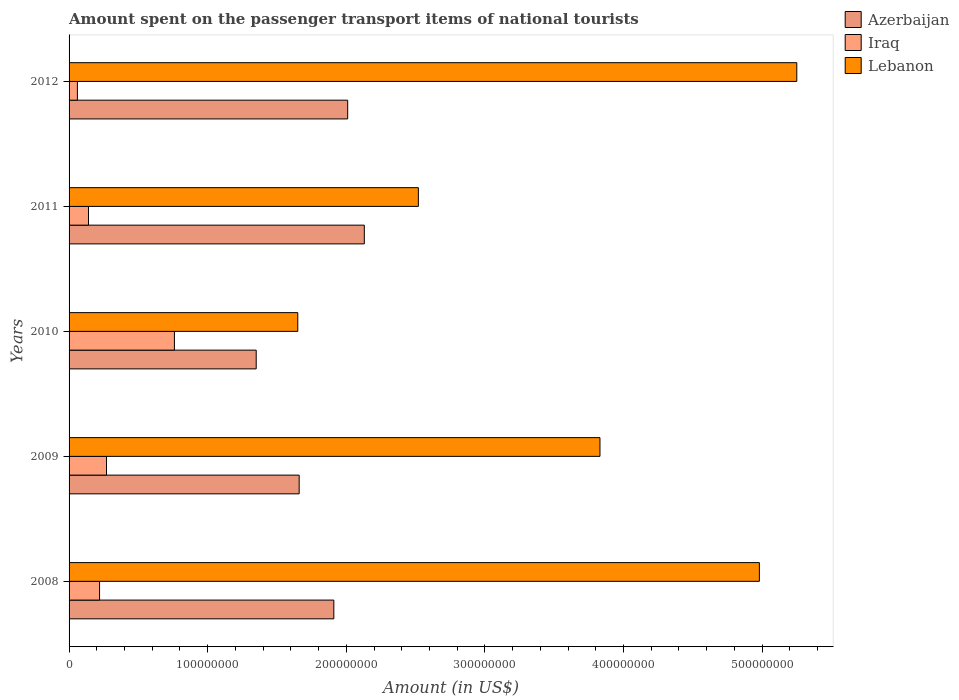How many different coloured bars are there?
Your response must be concise. 3. Are the number of bars per tick equal to the number of legend labels?
Your response must be concise. Yes. How many bars are there on the 4th tick from the bottom?
Keep it short and to the point. 3. In how many cases, is the number of bars for a given year not equal to the number of legend labels?
Your answer should be compact. 0. What is the amount spent on the passenger transport items of national tourists in Azerbaijan in 2009?
Your answer should be very brief. 1.66e+08. Across all years, what is the maximum amount spent on the passenger transport items of national tourists in Iraq?
Keep it short and to the point. 7.60e+07. Across all years, what is the minimum amount spent on the passenger transport items of national tourists in Lebanon?
Keep it short and to the point. 1.65e+08. In which year was the amount spent on the passenger transport items of national tourists in Azerbaijan maximum?
Give a very brief answer. 2011. In which year was the amount spent on the passenger transport items of national tourists in Azerbaijan minimum?
Offer a very short reply. 2010. What is the total amount spent on the passenger transport items of national tourists in Azerbaijan in the graph?
Provide a succinct answer. 9.06e+08. What is the difference between the amount spent on the passenger transport items of national tourists in Azerbaijan in 2008 and that in 2011?
Give a very brief answer. -2.20e+07. What is the difference between the amount spent on the passenger transport items of national tourists in Azerbaijan in 2011 and the amount spent on the passenger transport items of national tourists in Iraq in 2012?
Provide a short and direct response. 2.07e+08. What is the average amount spent on the passenger transport items of national tourists in Azerbaijan per year?
Your response must be concise. 1.81e+08. In the year 2011, what is the difference between the amount spent on the passenger transport items of national tourists in Iraq and amount spent on the passenger transport items of national tourists in Azerbaijan?
Provide a succinct answer. -1.99e+08. In how many years, is the amount spent on the passenger transport items of national tourists in Azerbaijan greater than 160000000 US$?
Keep it short and to the point. 4. What is the ratio of the amount spent on the passenger transport items of national tourists in Azerbaijan in 2009 to that in 2010?
Your response must be concise. 1.23. Is the difference between the amount spent on the passenger transport items of national tourists in Iraq in 2010 and 2011 greater than the difference between the amount spent on the passenger transport items of national tourists in Azerbaijan in 2010 and 2011?
Provide a succinct answer. Yes. What is the difference between the highest and the second highest amount spent on the passenger transport items of national tourists in Lebanon?
Ensure brevity in your answer.  2.70e+07. What is the difference between the highest and the lowest amount spent on the passenger transport items of national tourists in Azerbaijan?
Your answer should be compact. 7.80e+07. Is the sum of the amount spent on the passenger transport items of national tourists in Iraq in 2010 and 2011 greater than the maximum amount spent on the passenger transport items of national tourists in Lebanon across all years?
Ensure brevity in your answer.  No. What does the 1st bar from the top in 2012 represents?
Give a very brief answer. Lebanon. What does the 2nd bar from the bottom in 2011 represents?
Ensure brevity in your answer.  Iraq. Is it the case that in every year, the sum of the amount spent on the passenger transport items of national tourists in Azerbaijan and amount spent on the passenger transport items of national tourists in Iraq is greater than the amount spent on the passenger transport items of national tourists in Lebanon?
Offer a terse response. No. How many bars are there?
Ensure brevity in your answer.  15. Are all the bars in the graph horizontal?
Provide a short and direct response. Yes. How many years are there in the graph?
Keep it short and to the point. 5. What is the difference between two consecutive major ticks on the X-axis?
Keep it short and to the point. 1.00e+08. Does the graph contain grids?
Your answer should be compact. No. Where does the legend appear in the graph?
Your response must be concise. Top right. How many legend labels are there?
Ensure brevity in your answer.  3. How are the legend labels stacked?
Offer a very short reply. Vertical. What is the title of the graph?
Keep it short and to the point. Amount spent on the passenger transport items of national tourists. What is the Amount (in US$) in Azerbaijan in 2008?
Your answer should be very brief. 1.91e+08. What is the Amount (in US$) of Iraq in 2008?
Provide a short and direct response. 2.20e+07. What is the Amount (in US$) of Lebanon in 2008?
Your response must be concise. 4.98e+08. What is the Amount (in US$) of Azerbaijan in 2009?
Provide a succinct answer. 1.66e+08. What is the Amount (in US$) of Iraq in 2009?
Keep it short and to the point. 2.70e+07. What is the Amount (in US$) of Lebanon in 2009?
Keep it short and to the point. 3.83e+08. What is the Amount (in US$) in Azerbaijan in 2010?
Give a very brief answer. 1.35e+08. What is the Amount (in US$) in Iraq in 2010?
Your response must be concise. 7.60e+07. What is the Amount (in US$) of Lebanon in 2010?
Give a very brief answer. 1.65e+08. What is the Amount (in US$) in Azerbaijan in 2011?
Make the answer very short. 2.13e+08. What is the Amount (in US$) of Iraq in 2011?
Provide a succinct answer. 1.40e+07. What is the Amount (in US$) in Lebanon in 2011?
Keep it short and to the point. 2.52e+08. What is the Amount (in US$) of Azerbaijan in 2012?
Provide a short and direct response. 2.01e+08. What is the Amount (in US$) of Iraq in 2012?
Give a very brief answer. 6.00e+06. What is the Amount (in US$) of Lebanon in 2012?
Give a very brief answer. 5.25e+08. Across all years, what is the maximum Amount (in US$) of Azerbaijan?
Your response must be concise. 2.13e+08. Across all years, what is the maximum Amount (in US$) of Iraq?
Your answer should be very brief. 7.60e+07. Across all years, what is the maximum Amount (in US$) in Lebanon?
Your response must be concise. 5.25e+08. Across all years, what is the minimum Amount (in US$) in Azerbaijan?
Make the answer very short. 1.35e+08. Across all years, what is the minimum Amount (in US$) in Lebanon?
Offer a very short reply. 1.65e+08. What is the total Amount (in US$) of Azerbaijan in the graph?
Provide a succinct answer. 9.06e+08. What is the total Amount (in US$) in Iraq in the graph?
Your response must be concise. 1.45e+08. What is the total Amount (in US$) in Lebanon in the graph?
Your answer should be compact. 1.82e+09. What is the difference between the Amount (in US$) in Azerbaijan in 2008 and that in 2009?
Offer a terse response. 2.50e+07. What is the difference between the Amount (in US$) in Iraq in 2008 and that in 2009?
Provide a short and direct response. -5.00e+06. What is the difference between the Amount (in US$) of Lebanon in 2008 and that in 2009?
Make the answer very short. 1.15e+08. What is the difference between the Amount (in US$) of Azerbaijan in 2008 and that in 2010?
Offer a terse response. 5.60e+07. What is the difference between the Amount (in US$) in Iraq in 2008 and that in 2010?
Provide a short and direct response. -5.40e+07. What is the difference between the Amount (in US$) of Lebanon in 2008 and that in 2010?
Keep it short and to the point. 3.33e+08. What is the difference between the Amount (in US$) of Azerbaijan in 2008 and that in 2011?
Offer a terse response. -2.20e+07. What is the difference between the Amount (in US$) in Iraq in 2008 and that in 2011?
Make the answer very short. 8.00e+06. What is the difference between the Amount (in US$) of Lebanon in 2008 and that in 2011?
Your response must be concise. 2.46e+08. What is the difference between the Amount (in US$) of Azerbaijan in 2008 and that in 2012?
Your answer should be very brief. -1.00e+07. What is the difference between the Amount (in US$) of Iraq in 2008 and that in 2012?
Your response must be concise. 1.60e+07. What is the difference between the Amount (in US$) in Lebanon in 2008 and that in 2012?
Make the answer very short. -2.70e+07. What is the difference between the Amount (in US$) in Azerbaijan in 2009 and that in 2010?
Your answer should be compact. 3.10e+07. What is the difference between the Amount (in US$) of Iraq in 2009 and that in 2010?
Make the answer very short. -4.90e+07. What is the difference between the Amount (in US$) of Lebanon in 2009 and that in 2010?
Your response must be concise. 2.18e+08. What is the difference between the Amount (in US$) in Azerbaijan in 2009 and that in 2011?
Give a very brief answer. -4.70e+07. What is the difference between the Amount (in US$) of Iraq in 2009 and that in 2011?
Your answer should be very brief. 1.30e+07. What is the difference between the Amount (in US$) in Lebanon in 2009 and that in 2011?
Ensure brevity in your answer.  1.31e+08. What is the difference between the Amount (in US$) in Azerbaijan in 2009 and that in 2012?
Your answer should be compact. -3.50e+07. What is the difference between the Amount (in US$) in Iraq in 2009 and that in 2012?
Ensure brevity in your answer.  2.10e+07. What is the difference between the Amount (in US$) of Lebanon in 2009 and that in 2012?
Provide a short and direct response. -1.42e+08. What is the difference between the Amount (in US$) in Azerbaijan in 2010 and that in 2011?
Offer a very short reply. -7.80e+07. What is the difference between the Amount (in US$) of Iraq in 2010 and that in 2011?
Make the answer very short. 6.20e+07. What is the difference between the Amount (in US$) in Lebanon in 2010 and that in 2011?
Give a very brief answer. -8.70e+07. What is the difference between the Amount (in US$) in Azerbaijan in 2010 and that in 2012?
Your answer should be compact. -6.60e+07. What is the difference between the Amount (in US$) of Iraq in 2010 and that in 2012?
Offer a very short reply. 7.00e+07. What is the difference between the Amount (in US$) in Lebanon in 2010 and that in 2012?
Make the answer very short. -3.60e+08. What is the difference between the Amount (in US$) of Lebanon in 2011 and that in 2012?
Ensure brevity in your answer.  -2.73e+08. What is the difference between the Amount (in US$) in Azerbaijan in 2008 and the Amount (in US$) in Iraq in 2009?
Make the answer very short. 1.64e+08. What is the difference between the Amount (in US$) of Azerbaijan in 2008 and the Amount (in US$) of Lebanon in 2009?
Provide a short and direct response. -1.92e+08. What is the difference between the Amount (in US$) of Iraq in 2008 and the Amount (in US$) of Lebanon in 2009?
Offer a very short reply. -3.61e+08. What is the difference between the Amount (in US$) in Azerbaijan in 2008 and the Amount (in US$) in Iraq in 2010?
Your response must be concise. 1.15e+08. What is the difference between the Amount (in US$) in Azerbaijan in 2008 and the Amount (in US$) in Lebanon in 2010?
Give a very brief answer. 2.60e+07. What is the difference between the Amount (in US$) of Iraq in 2008 and the Amount (in US$) of Lebanon in 2010?
Your response must be concise. -1.43e+08. What is the difference between the Amount (in US$) in Azerbaijan in 2008 and the Amount (in US$) in Iraq in 2011?
Your response must be concise. 1.77e+08. What is the difference between the Amount (in US$) in Azerbaijan in 2008 and the Amount (in US$) in Lebanon in 2011?
Ensure brevity in your answer.  -6.10e+07. What is the difference between the Amount (in US$) of Iraq in 2008 and the Amount (in US$) of Lebanon in 2011?
Provide a succinct answer. -2.30e+08. What is the difference between the Amount (in US$) of Azerbaijan in 2008 and the Amount (in US$) of Iraq in 2012?
Keep it short and to the point. 1.85e+08. What is the difference between the Amount (in US$) of Azerbaijan in 2008 and the Amount (in US$) of Lebanon in 2012?
Ensure brevity in your answer.  -3.34e+08. What is the difference between the Amount (in US$) of Iraq in 2008 and the Amount (in US$) of Lebanon in 2012?
Offer a terse response. -5.03e+08. What is the difference between the Amount (in US$) of Azerbaijan in 2009 and the Amount (in US$) of Iraq in 2010?
Offer a terse response. 9.00e+07. What is the difference between the Amount (in US$) of Iraq in 2009 and the Amount (in US$) of Lebanon in 2010?
Keep it short and to the point. -1.38e+08. What is the difference between the Amount (in US$) of Azerbaijan in 2009 and the Amount (in US$) of Iraq in 2011?
Provide a succinct answer. 1.52e+08. What is the difference between the Amount (in US$) in Azerbaijan in 2009 and the Amount (in US$) in Lebanon in 2011?
Ensure brevity in your answer.  -8.60e+07. What is the difference between the Amount (in US$) of Iraq in 2009 and the Amount (in US$) of Lebanon in 2011?
Provide a succinct answer. -2.25e+08. What is the difference between the Amount (in US$) in Azerbaijan in 2009 and the Amount (in US$) in Iraq in 2012?
Give a very brief answer. 1.60e+08. What is the difference between the Amount (in US$) in Azerbaijan in 2009 and the Amount (in US$) in Lebanon in 2012?
Ensure brevity in your answer.  -3.59e+08. What is the difference between the Amount (in US$) in Iraq in 2009 and the Amount (in US$) in Lebanon in 2012?
Provide a succinct answer. -4.98e+08. What is the difference between the Amount (in US$) of Azerbaijan in 2010 and the Amount (in US$) of Iraq in 2011?
Your response must be concise. 1.21e+08. What is the difference between the Amount (in US$) in Azerbaijan in 2010 and the Amount (in US$) in Lebanon in 2011?
Your response must be concise. -1.17e+08. What is the difference between the Amount (in US$) in Iraq in 2010 and the Amount (in US$) in Lebanon in 2011?
Offer a terse response. -1.76e+08. What is the difference between the Amount (in US$) in Azerbaijan in 2010 and the Amount (in US$) in Iraq in 2012?
Give a very brief answer. 1.29e+08. What is the difference between the Amount (in US$) in Azerbaijan in 2010 and the Amount (in US$) in Lebanon in 2012?
Your answer should be very brief. -3.90e+08. What is the difference between the Amount (in US$) in Iraq in 2010 and the Amount (in US$) in Lebanon in 2012?
Your response must be concise. -4.49e+08. What is the difference between the Amount (in US$) of Azerbaijan in 2011 and the Amount (in US$) of Iraq in 2012?
Your answer should be very brief. 2.07e+08. What is the difference between the Amount (in US$) in Azerbaijan in 2011 and the Amount (in US$) in Lebanon in 2012?
Keep it short and to the point. -3.12e+08. What is the difference between the Amount (in US$) in Iraq in 2011 and the Amount (in US$) in Lebanon in 2012?
Offer a terse response. -5.11e+08. What is the average Amount (in US$) in Azerbaijan per year?
Provide a short and direct response. 1.81e+08. What is the average Amount (in US$) of Iraq per year?
Give a very brief answer. 2.90e+07. What is the average Amount (in US$) in Lebanon per year?
Keep it short and to the point. 3.65e+08. In the year 2008, what is the difference between the Amount (in US$) in Azerbaijan and Amount (in US$) in Iraq?
Give a very brief answer. 1.69e+08. In the year 2008, what is the difference between the Amount (in US$) in Azerbaijan and Amount (in US$) in Lebanon?
Give a very brief answer. -3.07e+08. In the year 2008, what is the difference between the Amount (in US$) of Iraq and Amount (in US$) of Lebanon?
Offer a terse response. -4.76e+08. In the year 2009, what is the difference between the Amount (in US$) in Azerbaijan and Amount (in US$) in Iraq?
Provide a short and direct response. 1.39e+08. In the year 2009, what is the difference between the Amount (in US$) in Azerbaijan and Amount (in US$) in Lebanon?
Offer a very short reply. -2.17e+08. In the year 2009, what is the difference between the Amount (in US$) of Iraq and Amount (in US$) of Lebanon?
Provide a succinct answer. -3.56e+08. In the year 2010, what is the difference between the Amount (in US$) of Azerbaijan and Amount (in US$) of Iraq?
Ensure brevity in your answer.  5.90e+07. In the year 2010, what is the difference between the Amount (in US$) of Azerbaijan and Amount (in US$) of Lebanon?
Offer a terse response. -3.00e+07. In the year 2010, what is the difference between the Amount (in US$) in Iraq and Amount (in US$) in Lebanon?
Provide a succinct answer. -8.90e+07. In the year 2011, what is the difference between the Amount (in US$) of Azerbaijan and Amount (in US$) of Iraq?
Your answer should be compact. 1.99e+08. In the year 2011, what is the difference between the Amount (in US$) of Azerbaijan and Amount (in US$) of Lebanon?
Ensure brevity in your answer.  -3.90e+07. In the year 2011, what is the difference between the Amount (in US$) of Iraq and Amount (in US$) of Lebanon?
Your response must be concise. -2.38e+08. In the year 2012, what is the difference between the Amount (in US$) in Azerbaijan and Amount (in US$) in Iraq?
Make the answer very short. 1.95e+08. In the year 2012, what is the difference between the Amount (in US$) of Azerbaijan and Amount (in US$) of Lebanon?
Offer a terse response. -3.24e+08. In the year 2012, what is the difference between the Amount (in US$) of Iraq and Amount (in US$) of Lebanon?
Make the answer very short. -5.19e+08. What is the ratio of the Amount (in US$) of Azerbaijan in 2008 to that in 2009?
Offer a very short reply. 1.15. What is the ratio of the Amount (in US$) in Iraq in 2008 to that in 2009?
Offer a terse response. 0.81. What is the ratio of the Amount (in US$) in Lebanon in 2008 to that in 2009?
Make the answer very short. 1.3. What is the ratio of the Amount (in US$) in Azerbaijan in 2008 to that in 2010?
Give a very brief answer. 1.41. What is the ratio of the Amount (in US$) of Iraq in 2008 to that in 2010?
Offer a very short reply. 0.29. What is the ratio of the Amount (in US$) of Lebanon in 2008 to that in 2010?
Make the answer very short. 3.02. What is the ratio of the Amount (in US$) of Azerbaijan in 2008 to that in 2011?
Your answer should be compact. 0.9. What is the ratio of the Amount (in US$) of Iraq in 2008 to that in 2011?
Your response must be concise. 1.57. What is the ratio of the Amount (in US$) in Lebanon in 2008 to that in 2011?
Your answer should be very brief. 1.98. What is the ratio of the Amount (in US$) in Azerbaijan in 2008 to that in 2012?
Provide a succinct answer. 0.95. What is the ratio of the Amount (in US$) in Iraq in 2008 to that in 2012?
Give a very brief answer. 3.67. What is the ratio of the Amount (in US$) of Lebanon in 2008 to that in 2012?
Your answer should be very brief. 0.95. What is the ratio of the Amount (in US$) of Azerbaijan in 2009 to that in 2010?
Provide a succinct answer. 1.23. What is the ratio of the Amount (in US$) in Iraq in 2009 to that in 2010?
Make the answer very short. 0.36. What is the ratio of the Amount (in US$) in Lebanon in 2009 to that in 2010?
Ensure brevity in your answer.  2.32. What is the ratio of the Amount (in US$) in Azerbaijan in 2009 to that in 2011?
Offer a terse response. 0.78. What is the ratio of the Amount (in US$) in Iraq in 2009 to that in 2011?
Provide a short and direct response. 1.93. What is the ratio of the Amount (in US$) in Lebanon in 2009 to that in 2011?
Offer a terse response. 1.52. What is the ratio of the Amount (in US$) in Azerbaijan in 2009 to that in 2012?
Offer a very short reply. 0.83. What is the ratio of the Amount (in US$) in Iraq in 2009 to that in 2012?
Your answer should be very brief. 4.5. What is the ratio of the Amount (in US$) in Lebanon in 2009 to that in 2012?
Your answer should be very brief. 0.73. What is the ratio of the Amount (in US$) of Azerbaijan in 2010 to that in 2011?
Offer a terse response. 0.63. What is the ratio of the Amount (in US$) in Iraq in 2010 to that in 2011?
Ensure brevity in your answer.  5.43. What is the ratio of the Amount (in US$) of Lebanon in 2010 to that in 2011?
Your answer should be compact. 0.65. What is the ratio of the Amount (in US$) of Azerbaijan in 2010 to that in 2012?
Offer a terse response. 0.67. What is the ratio of the Amount (in US$) in Iraq in 2010 to that in 2012?
Ensure brevity in your answer.  12.67. What is the ratio of the Amount (in US$) of Lebanon in 2010 to that in 2012?
Offer a very short reply. 0.31. What is the ratio of the Amount (in US$) of Azerbaijan in 2011 to that in 2012?
Ensure brevity in your answer.  1.06. What is the ratio of the Amount (in US$) in Iraq in 2011 to that in 2012?
Make the answer very short. 2.33. What is the ratio of the Amount (in US$) in Lebanon in 2011 to that in 2012?
Offer a very short reply. 0.48. What is the difference between the highest and the second highest Amount (in US$) in Iraq?
Give a very brief answer. 4.90e+07. What is the difference between the highest and the second highest Amount (in US$) in Lebanon?
Make the answer very short. 2.70e+07. What is the difference between the highest and the lowest Amount (in US$) of Azerbaijan?
Make the answer very short. 7.80e+07. What is the difference between the highest and the lowest Amount (in US$) in Iraq?
Give a very brief answer. 7.00e+07. What is the difference between the highest and the lowest Amount (in US$) of Lebanon?
Offer a very short reply. 3.60e+08. 